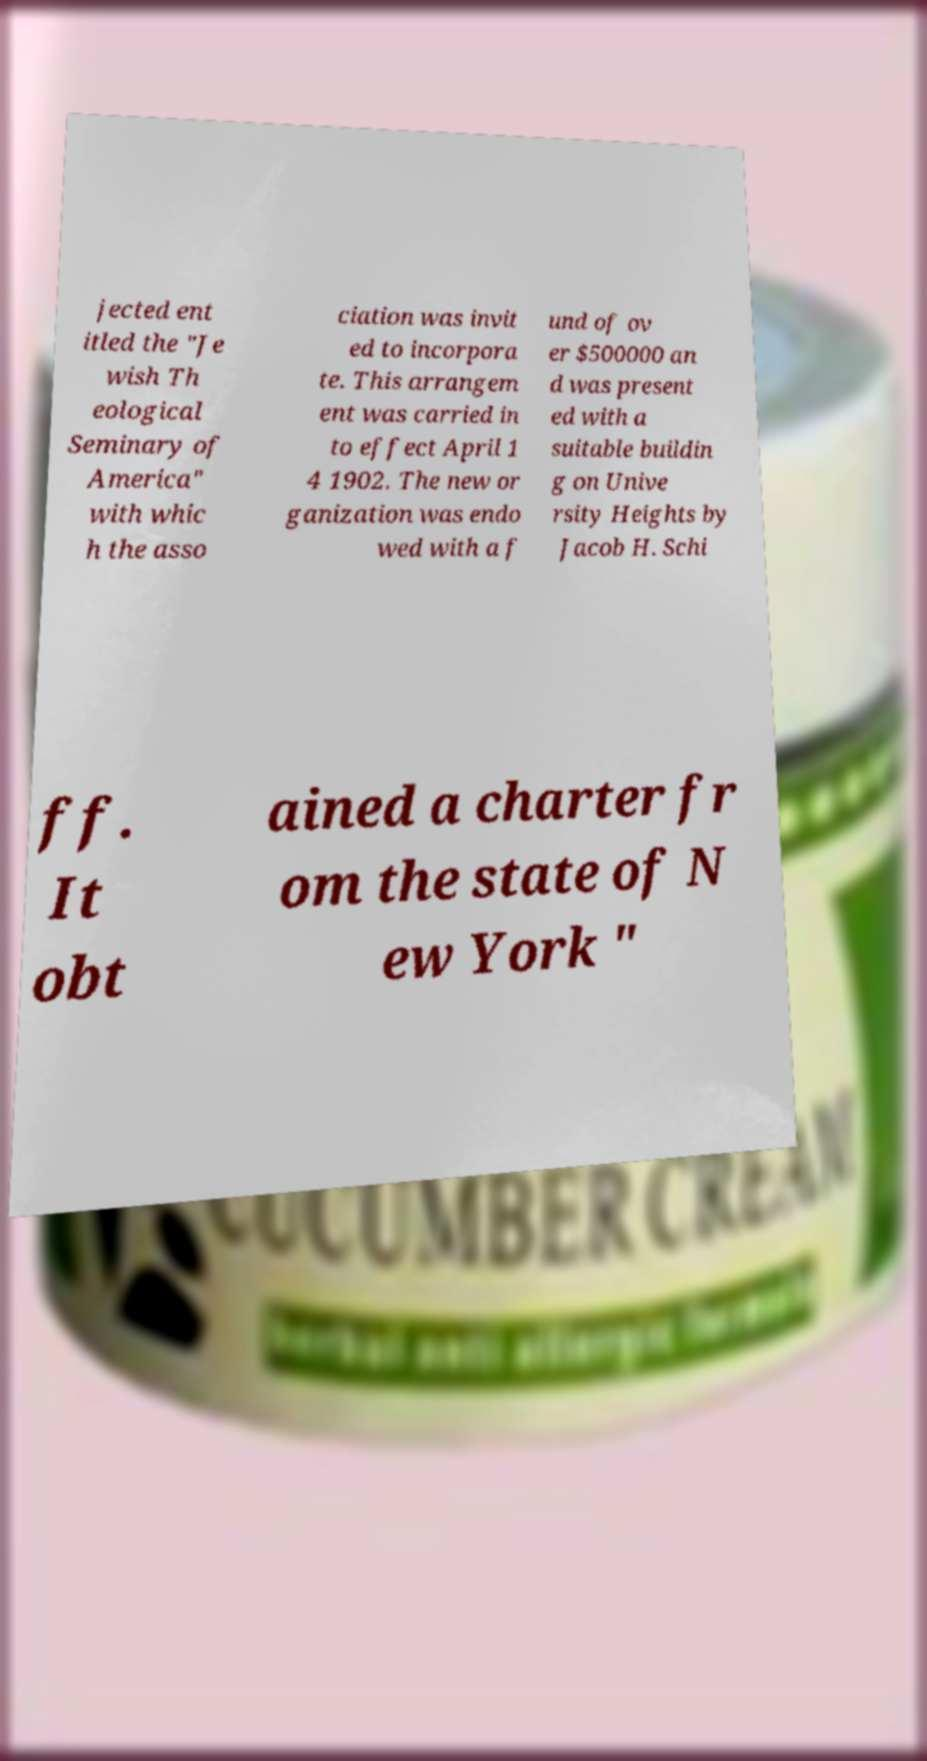For documentation purposes, I need the text within this image transcribed. Could you provide that? jected ent itled the "Je wish Th eological Seminary of America" with whic h the asso ciation was invit ed to incorpora te. This arrangem ent was carried in to effect April 1 4 1902. The new or ganization was endo wed with a f und of ov er $500000 an d was present ed with a suitable buildin g on Unive rsity Heights by Jacob H. Schi ff. It obt ained a charter fr om the state of N ew York " 